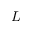<formula> <loc_0><loc_0><loc_500><loc_500>L</formula> 